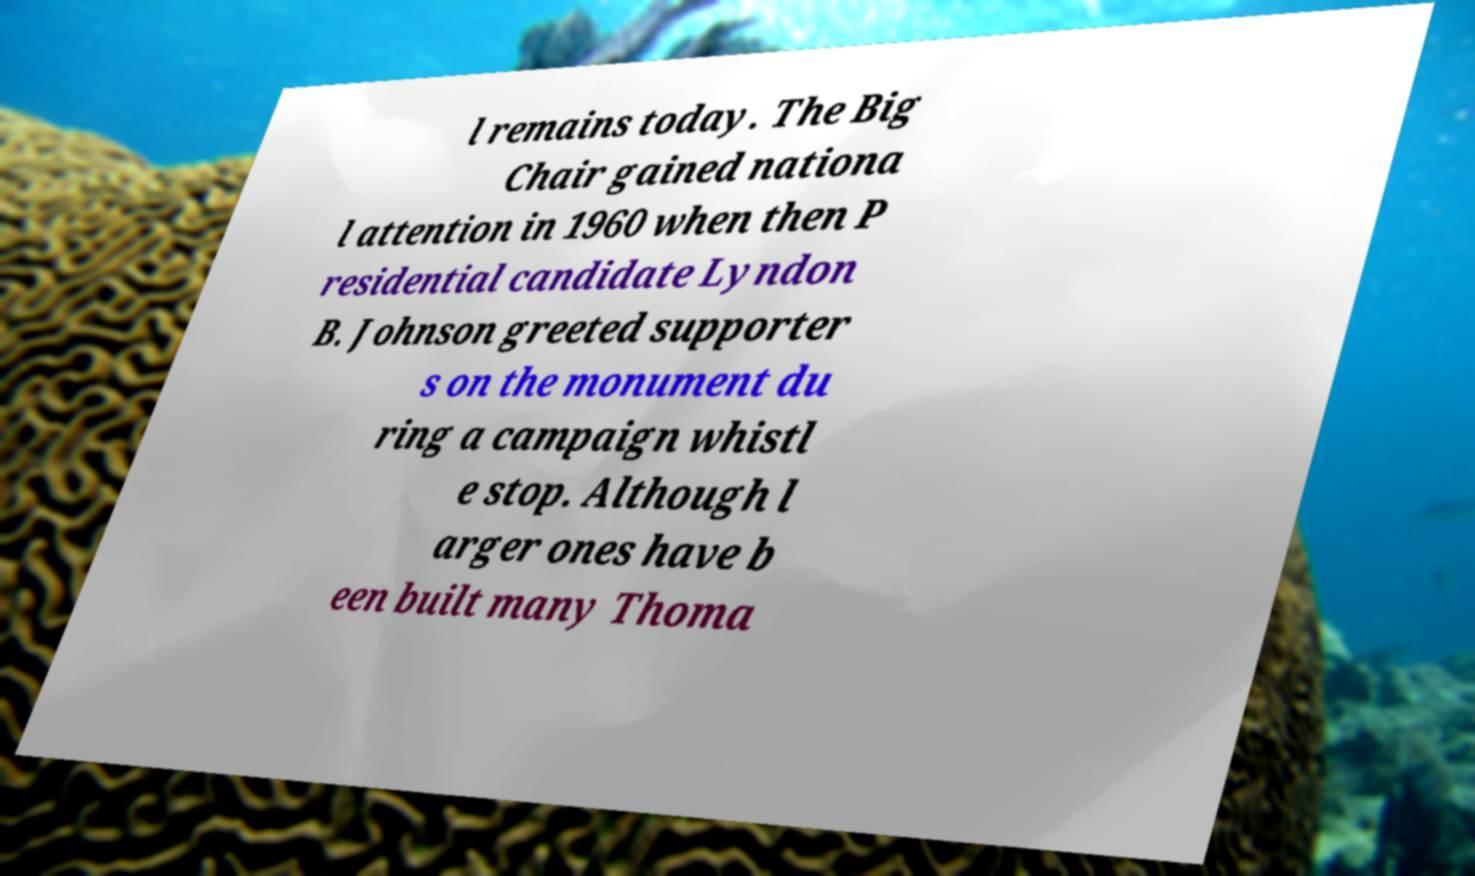There's text embedded in this image that I need extracted. Can you transcribe it verbatim? l remains today. The Big Chair gained nationa l attention in 1960 when then P residential candidate Lyndon B. Johnson greeted supporter s on the monument du ring a campaign whistl e stop. Although l arger ones have b een built many Thoma 